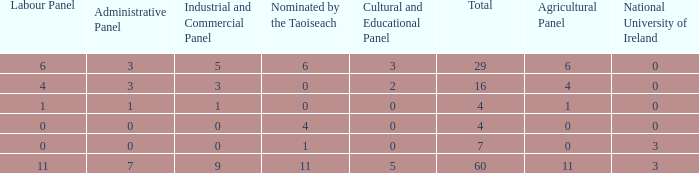What is the total number of agriculatural panels of the composition with more than 3 National Universities of Ireland? 0.0. 